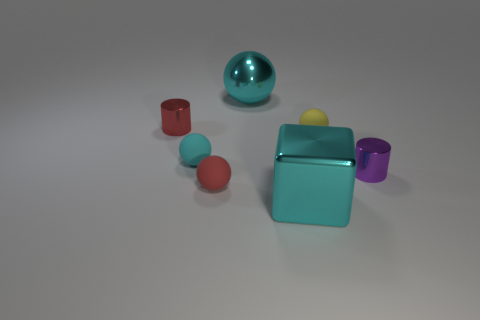Subtract all cyan balls. Subtract all blue cubes. How many balls are left? 2 Add 1 cyan matte things. How many objects exist? 8 Subtract all blocks. How many objects are left? 6 Add 7 cyan matte things. How many cyan matte things exist? 8 Subtract 0 gray cubes. How many objects are left? 7 Subtract all tiny rubber things. Subtract all big cyan spheres. How many objects are left? 3 Add 5 cyan metal balls. How many cyan metal balls are left? 6 